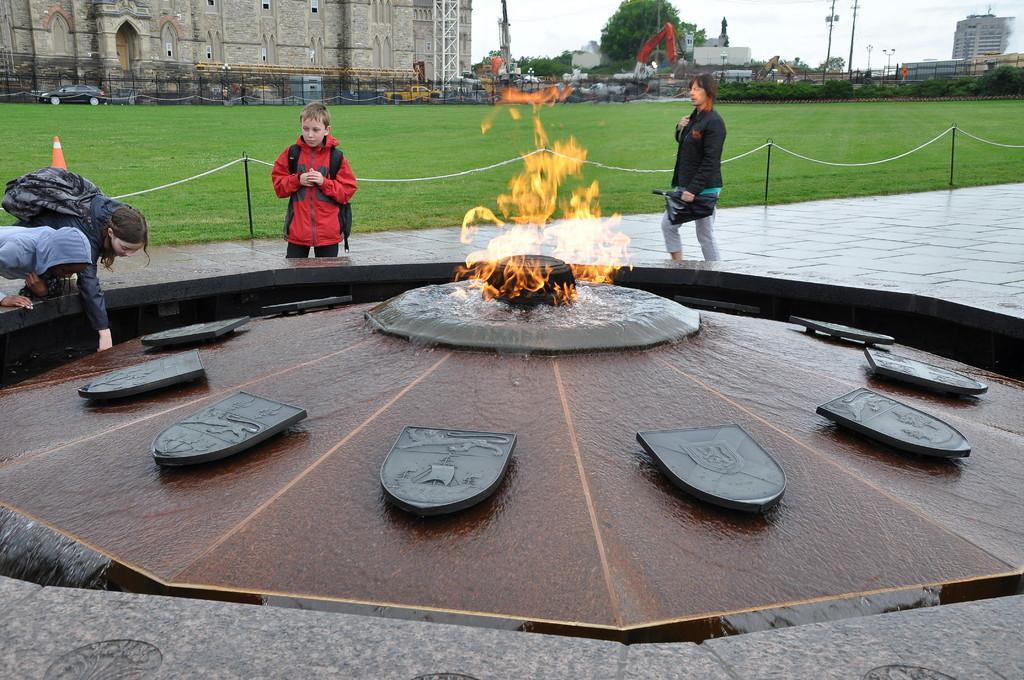Please provide a concise description of this image. In the image there is fire and around the fire there is water surface it is a beautiful construction and around that there are three people, behind them there is a garden and behind the garden there is a building, trees and other things. 